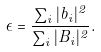<formula> <loc_0><loc_0><loc_500><loc_500>\epsilon = \frac { \sum _ { i } | { b _ { i } } | ^ { 2 } } { \sum _ { i } | { B _ { i } } | ^ { 2 } } .</formula> 